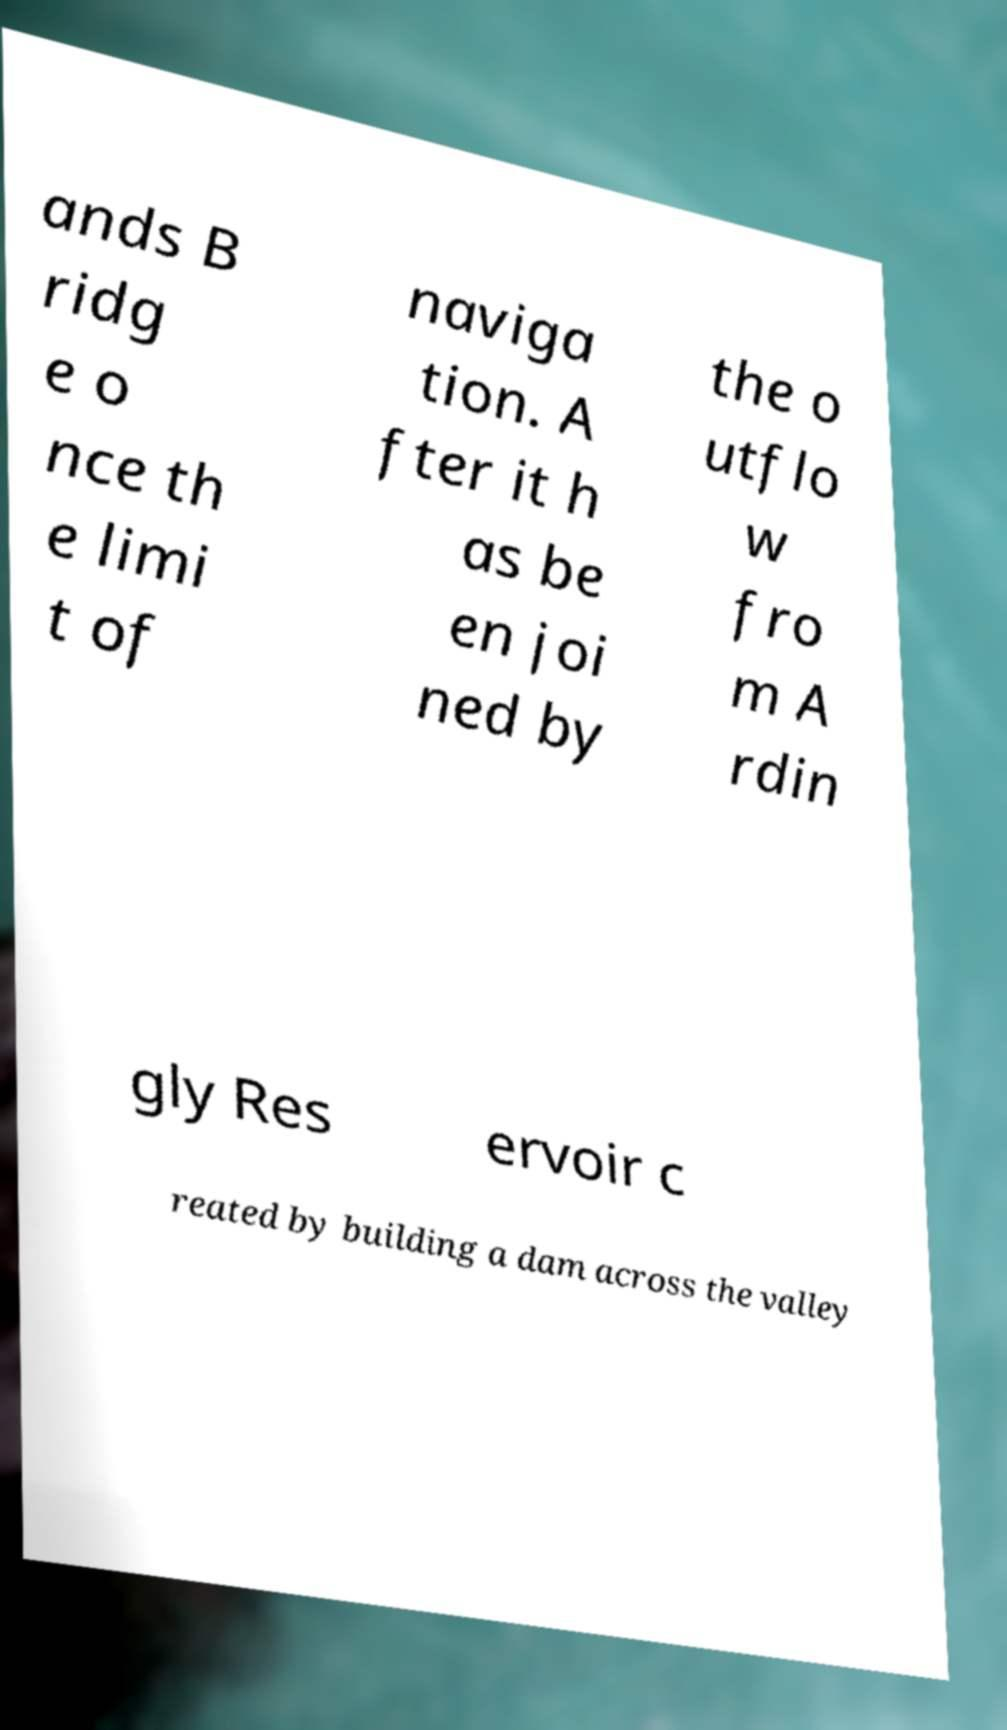Please read and relay the text visible in this image. What does it say? ands B ridg e o nce th e limi t of naviga tion. A fter it h as be en joi ned by the o utflo w fro m A rdin gly Res ervoir c reated by building a dam across the valley 